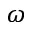<formula> <loc_0><loc_0><loc_500><loc_500>\omega</formula> 